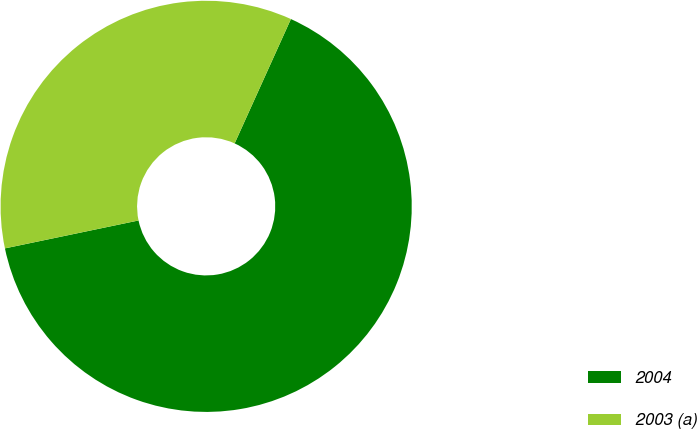<chart> <loc_0><loc_0><loc_500><loc_500><pie_chart><fcel>2004<fcel>2003 (a)<nl><fcel>64.96%<fcel>35.04%<nl></chart> 